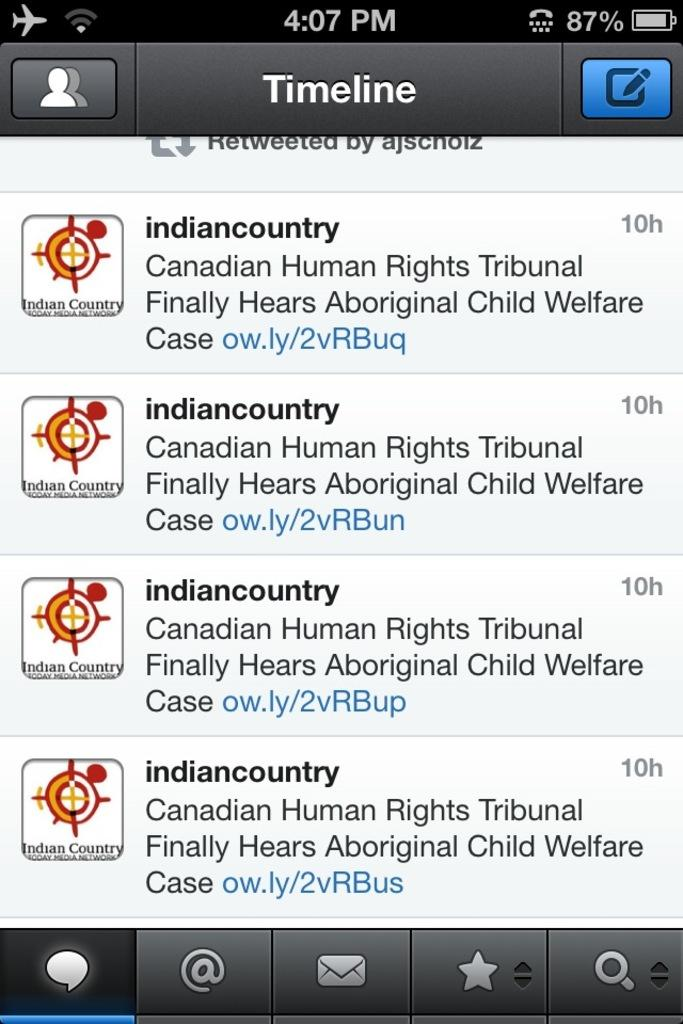<image>
Share a concise interpretation of the image provided. The ads on the phone are from Indian Country 